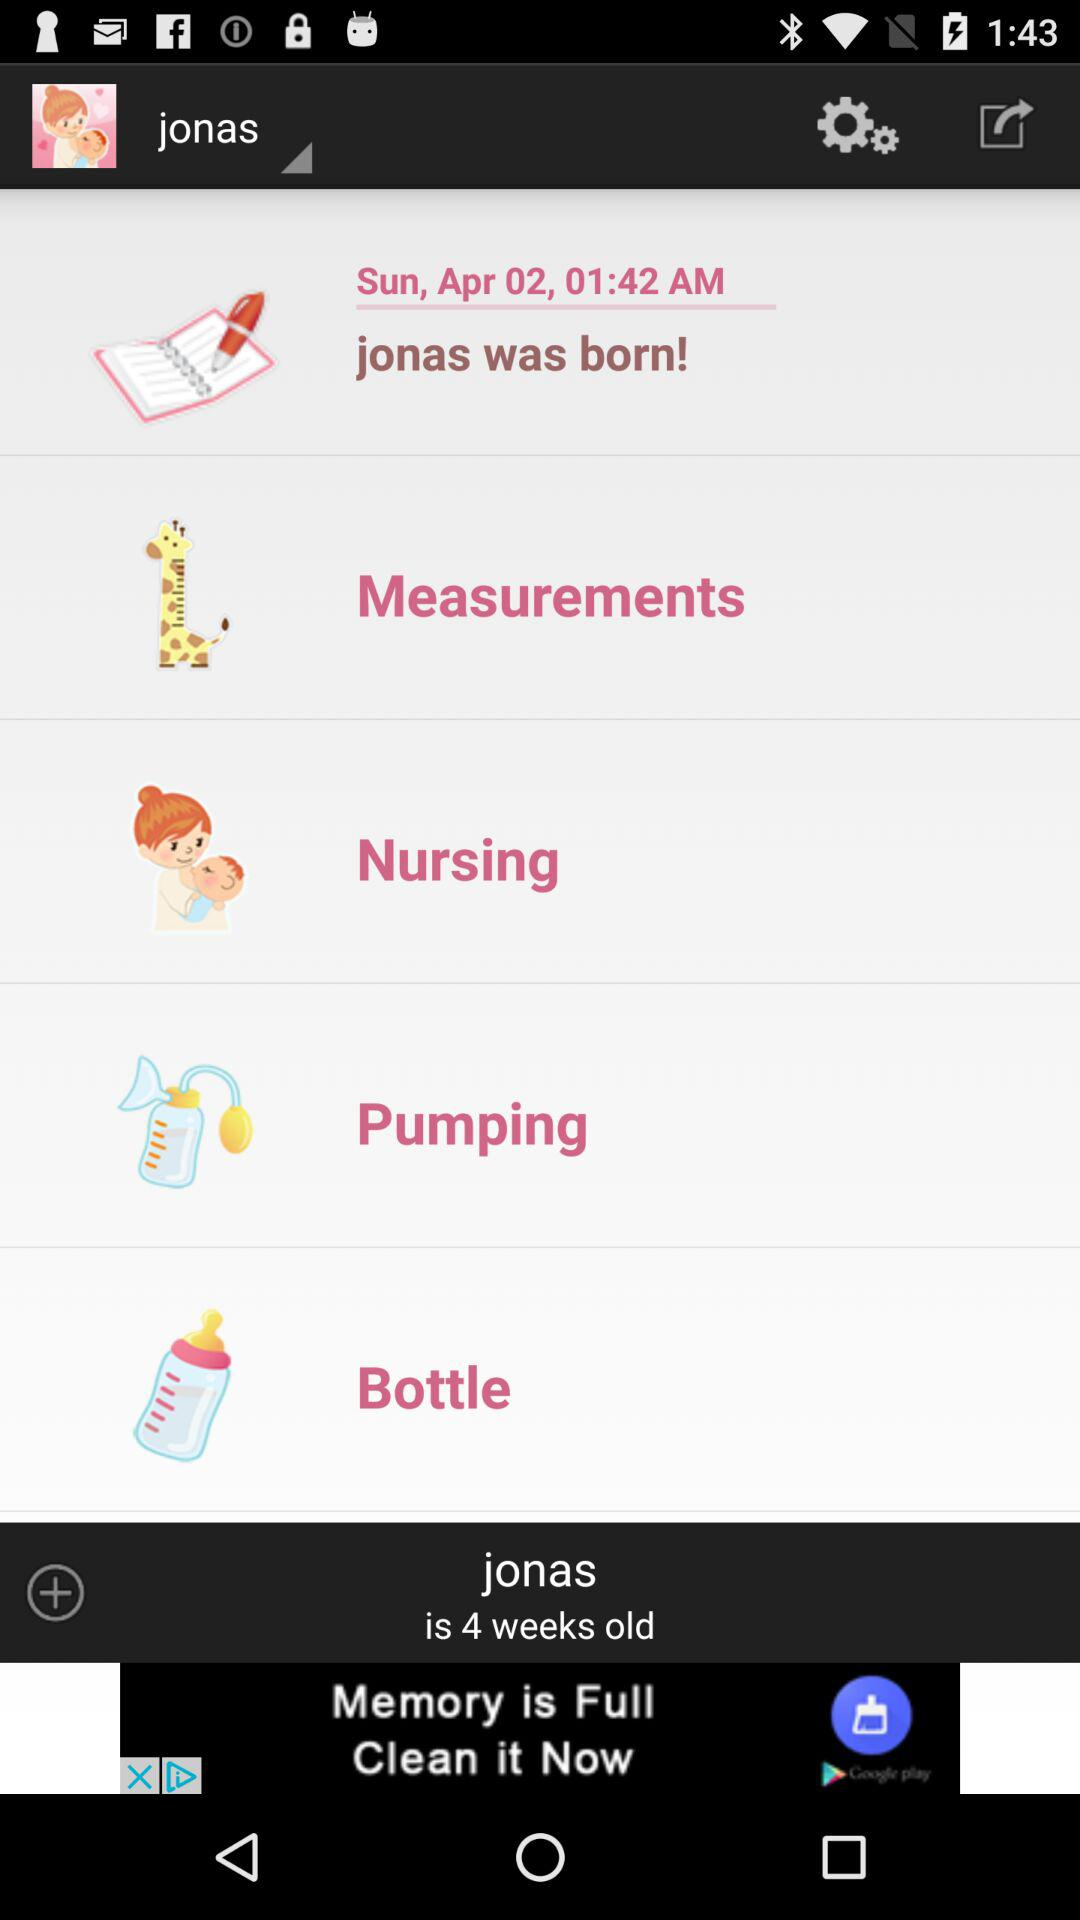At which time Jonas was born? Jonas was born at 1:42 a.m. 